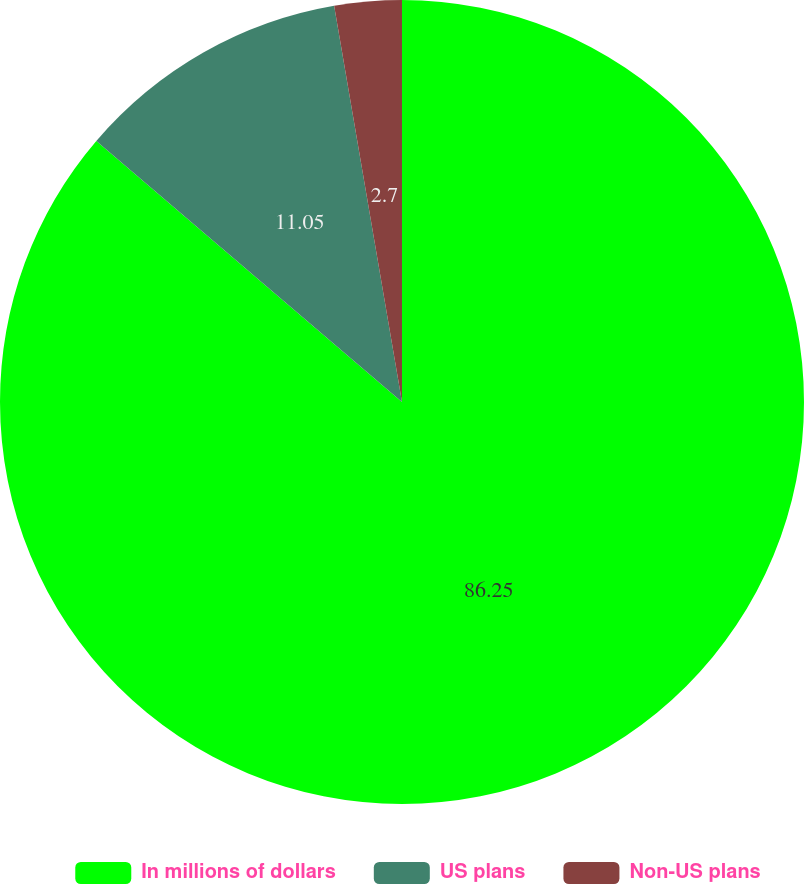Convert chart to OTSL. <chart><loc_0><loc_0><loc_500><loc_500><pie_chart><fcel>In millions of dollars<fcel>US plans<fcel>Non-US plans<nl><fcel>86.25%<fcel>11.05%<fcel>2.7%<nl></chart> 